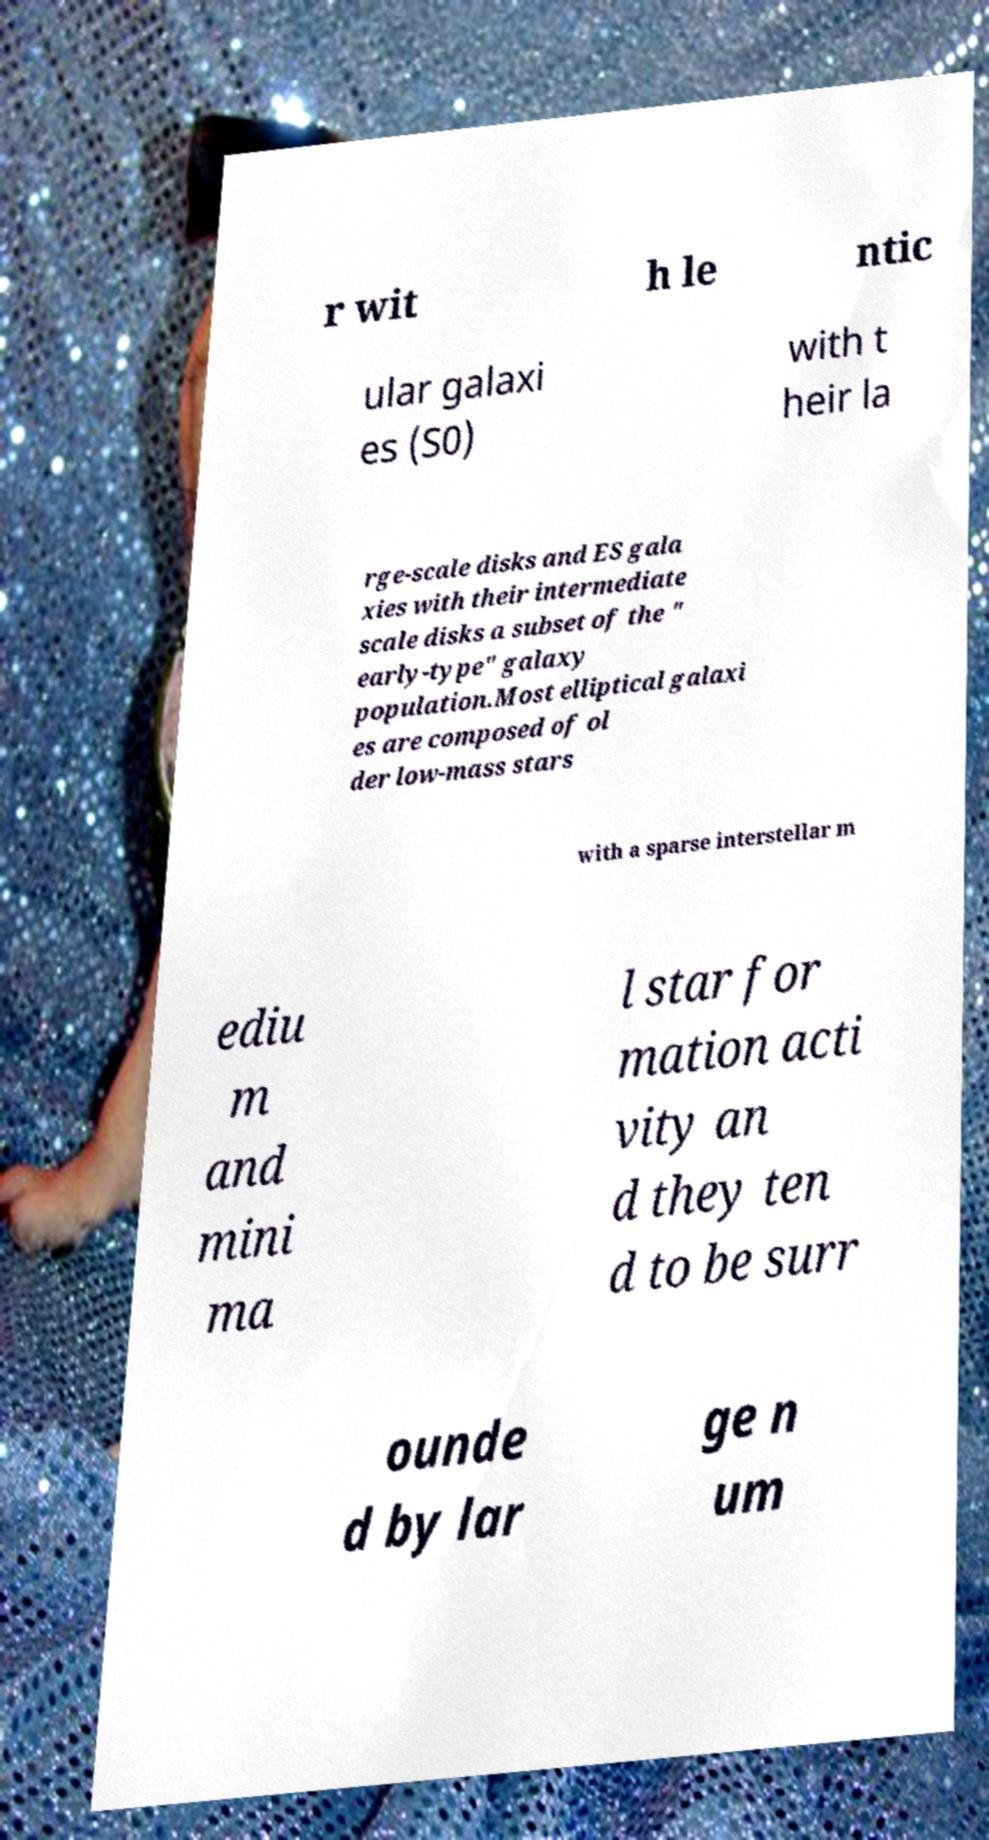For documentation purposes, I need the text within this image transcribed. Could you provide that? r wit h le ntic ular galaxi es (S0) with t heir la rge-scale disks and ES gala xies with their intermediate scale disks a subset of the " early-type" galaxy population.Most elliptical galaxi es are composed of ol der low-mass stars with a sparse interstellar m ediu m and mini ma l star for mation acti vity an d they ten d to be surr ounde d by lar ge n um 